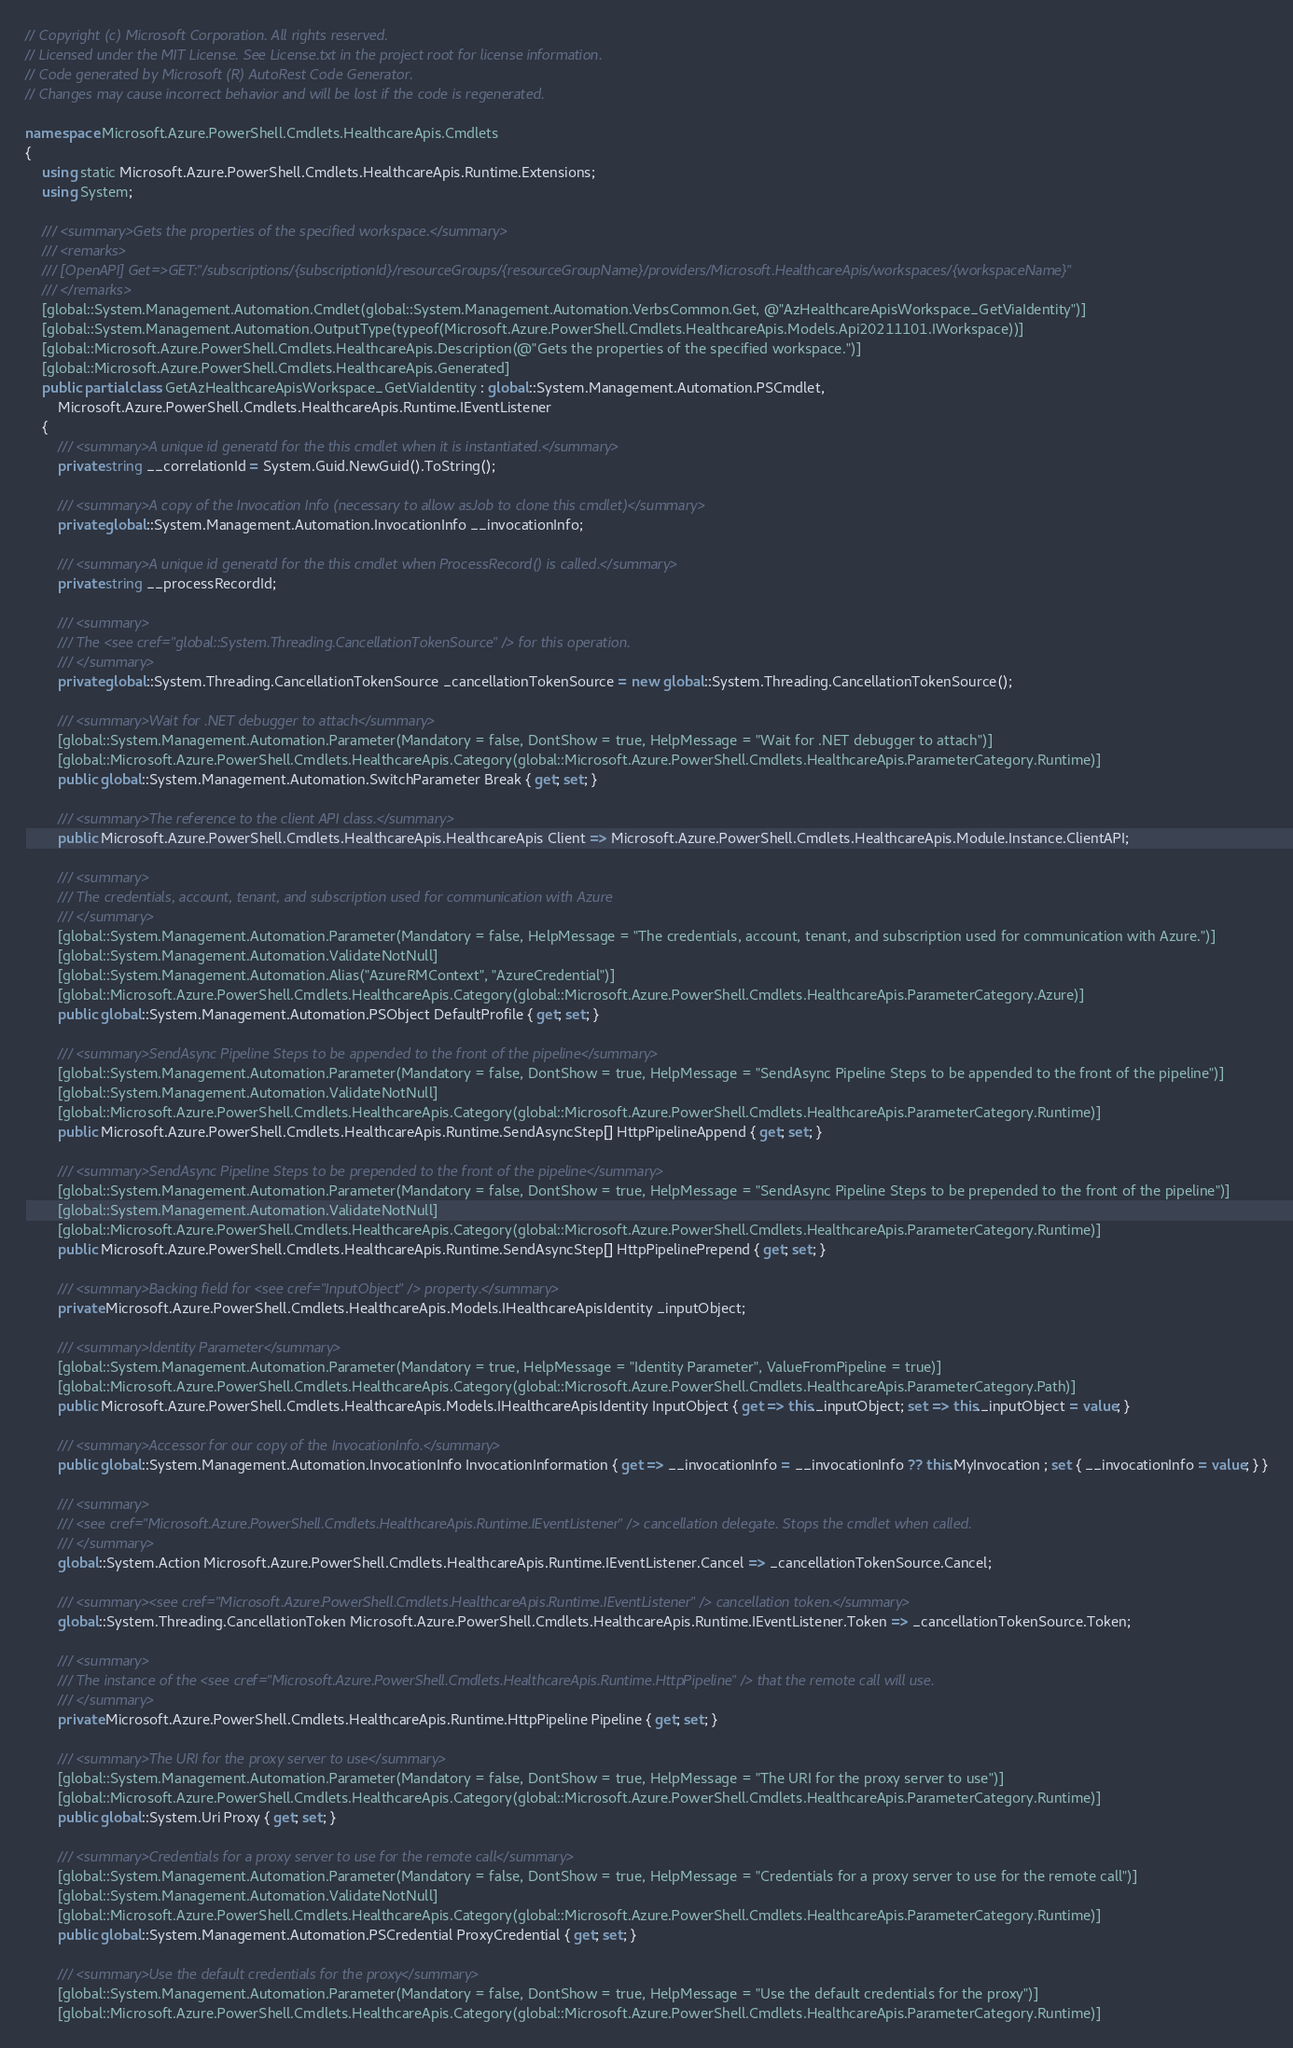Convert code to text. <code><loc_0><loc_0><loc_500><loc_500><_C#_>// Copyright (c) Microsoft Corporation. All rights reserved.
// Licensed under the MIT License. See License.txt in the project root for license information.
// Code generated by Microsoft (R) AutoRest Code Generator.
// Changes may cause incorrect behavior and will be lost if the code is regenerated.

namespace Microsoft.Azure.PowerShell.Cmdlets.HealthcareApis.Cmdlets
{
    using static Microsoft.Azure.PowerShell.Cmdlets.HealthcareApis.Runtime.Extensions;
    using System;

    /// <summary>Gets the properties of the specified workspace.</summary>
    /// <remarks>
    /// [OpenAPI] Get=>GET:"/subscriptions/{subscriptionId}/resourceGroups/{resourceGroupName}/providers/Microsoft.HealthcareApis/workspaces/{workspaceName}"
    /// </remarks>
    [global::System.Management.Automation.Cmdlet(global::System.Management.Automation.VerbsCommon.Get, @"AzHealthcareApisWorkspace_GetViaIdentity")]
    [global::System.Management.Automation.OutputType(typeof(Microsoft.Azure.PowerShell.Cmdlets.HealthcareApis.Models.Api20211101.IWorkspace))]
    [global::Microsoft.Azure.PowerShell.Cmdlets.HealthcareApis.Description(@"Gets the properties of the specified workspace.")]
    [global::Microsoft.Azure.PowerShell.Cmdlets.HealthcareApis.Generated]
    public partial class GetAzHealthcareApisWorkspace_GetViaIdentity : global::System.Management.Automation.PSCmdlet,
        Microsoft.Azure.PowerShell.Cmdlets.HealthcareApis.Runtime.IEventListener
    {
        /// <summary>A unique id generatd for the this cmdlet when it is instantiated.</summary>
        private string __correlationId = System.Guid.NewGuid().ToString();

        /// <summary>A copy of the Invocation Info (necessary to allow asJob to clone this cmdlet)</summary>
        private global::System.Management.Automation.InvocationInfo __invocationInfo;

        /// <summary>A unique id generatd for the this cmdlet when ProcessRecord() is called.</summary>
        private string __processRecordId;

        /// <summary>
        /// The <see cref="global::System.Threading.CancellationTokenSource" /> for this operation.
        /// </summary>
        private global::System.Threading.CancellationTokenSource _cancellationTokenSource = new global::System.Threading.CancellationTokenSource();

        /// <summary>Wait for .NET debugger to attach</summary>
        [global::System.Management.Automation.Parameter(Mandatory = false, DontShow = true, HelpMessage = "Wait for .NET debugger to attach")]
        [global::Microsoft.Azure.PowerShell.Cmdlets.HealthcareApis.Category(global::Microsoft.Azure.PowerShell.Cmdlets.HealthcareApis.ParameterCategory.Runtime)]
        public global::System.Management.Automation.SwitchParameter Break { get; set; }

        /// <summary>The reference to the client API class.</summary>
        public Microsoft.Azure.PowerShell.Cmdlets.HealthcareApis.HealthcareApis Client => Microsoft.Azure.PowerShell.Cmdlets.HealthcareApis.Module.Instance.ClientAPI;

        /// <summary>
        /// The credentials, account, tenant, and subscription used for communication with Azure
        /// </summary>
        [global::System.Management.Automation.Parameter(Mandatory = false, HelpMessage = "The credentials, account, tenant, and subscription used for communication with Azure.")]
        [global::System.Management.Automation.ValidateNotNull]
        [global::System.Management.Automation.Alias("AzureRMContext", "AzureCredential")]
        [global::Microsoft.Azure.PowerShell.Cmdlets.HealthcareApis.Category(global::Microsoft.Azure.PowerShell.Cmdlets.HealthcareApis.ParameterCategory.Azure)]
        public global::System.Management.Automation.PSObject DefaultProfile { get; set; }

        /// <summary>SendAsync Pipeline Steps to be appended to the front of the pipeline</summary>
        [global::System.Management.Automation.Parameter(Mandatory = false, DontShow = true, HelpMessage = "SendAsync Pipeline Steps to be appended to the front of the pipeline")]
        [global::System.Management.Automation.ValidateNotNull]
        [global::Microsoft.Azure.PowerShell.Cmdlets.HealthcareApis.Category(global::Microsoft.Azure.PowerShell.Cmdlets.HealthcareApis.ParameterCategory.Runtime)]
        public Microsoft.Azure.PowerShell.Cmdlets.HealthcareApis.Runtime.SendAsyncStep[] HttpPipelineAppend { get; set; }

        /// <summary>SendAsync Pipeline Steps to be prepended to the front of the pipeline</summary>
        [global::System.Management.Automation.Parameter(Mandatory = false, DontShow = true, HelpMessage = "SendAsync Pipeline Steps to be prepended to the front of the pipeline")]
        [global::System.Management.Automation.ValidateNotNull]
        [global::Microsoft.Azure.PowerShell.Cmdlets.HealthcareApis.Category(global::Microsoft.Azure.PowerShell.Cmdlets.HealthcareApis.ParameterCategory.Runtime)]
        public Microsoft.Azure.PowerShell.Cmdlets.HealthcareApis.Runtime.SendAsyncStep[] HttpPipelinePrepend { get; set; }

        /// <summary>Backing field for <see cref="InputObject" /> property.</summary>
        private Microsoft.Azure.PowerShell.Cmdlets.HealthcareApis.Models.IHealthcareApisIdentity _inputObject;

        /// <summary>Identity Parameter</summary>
        [global::System.Management.Automation.Parameter(Mandatory = true, HelpMessage = "Identity Parameter", ValueFromPipeline = true)]
        [global::Microsoft.Azure.PowerShell.Cmdlets.HealthcareApis.Category(global::Microsoft.Azure.PowerShell.Cmdlets.HealthcareApis.ParameterCategory.Path)]
        public Microsoft.Azure.PowerShell.Cmdlets.HealthcareApis.Models.IHealthcareApisIdentity InputObject { get => this._inputObject; set => this._inputObject = value; }

        /// <summary>Accessor for our copy of the InvocationInfo.</summary>
        public global::System.Management.Automation.InvocationInfo InvocationInformation { get => __invocationInfo = __invocationInfo ?? this.MyInvocation ; set { __invocationInfo = value; } }

        /// <summary>
        /// <see cref="Microsoft.Azure.PowerShell.Cmdlets.HealthcareApis.Runtime.IEventListener" /> cancellation delegate. Stops the cmdlet when called.
        /// </summary>
        global::System.Action Microsoft.Azure.PowerShell.Cmdlets.HealthcareApis.Runtime.IEventListener.Cancel => _cancellationTokenSource.Cancel;

        /// <summary><see cref="Microsoft.Azure.PowerShell.Cmdlets.HealthcareApis.Runtime.IEventListener" /> cancellation token.</summary>
        global::System.Threading.CancellationToken Microsoft.Azure.PowerShell.Cmdlets.HealthcareApis.Runtime.IEventListener.Token => _cancellationTokenSource.Token;

        /// <summary>
        /// The instance of the <see cref="Microsoft.Azure.PowerShell.Cmdlets.HealthcareApis.Runtime.HttpPipeline" /> that the remote call will use.
        /// </summary>
        private Microsoft.Azure.PowerShell.Cmdlets.HealthcareApis.Runtime.HttpPipeline Pipeline { get; set; }

        /// <summary>The URI for the proxy server to use</summary>
        [global::System.Management.Automation.Parameter(Mandatory = false, DontShow = true, HelpMessage = "The URI for the proxy server to use")]
        [global::Microsoft.Azure.PowerShell.Cmdlets.HealthcareApis.Category(global::Microsoft.Azure.PowerShell.Cmdlets.HealthcareApis.ParameterCategory.Runtime)]
        public global::System.Uri Proxy { get; set; }

        /// <summary>Credentials for a proxy server to use for the remote call</summary>
        [global::System.Management.Automation.Parameter(Mandatory = false, DontShow = true, HelpMessage = "Credentials for a proxy server to use for the remote call")]
        [global::System.Management.Automation.ValidateNotNull]
        [global::Microsoft.Azure.PowerShell.Cmdlets.HealthcareApis.Category(global::Microsoft.Azure.PowerShell.Cmdlets.HealthcareApis.ParameterCategory.Runtime)]
        public global::System.Management.Automation.PSCredential ProxyCredential { get; set; }

        /// <summary>Use the default credentials for the proxy</summary>
        [global::System.Management.Automation.Parameter(Mandatory = false, DontShow = true, HelpMessage = "Use the default credentials for the proxy")]
        [global::Microsoft.Azure.PowerShell.Cmdlets.HealthcareApis.Category(global::Microsoft.Azure.PowerShell.Cmdlets.HealthcareApis.ParameterCategory.Runtime)]</code> 